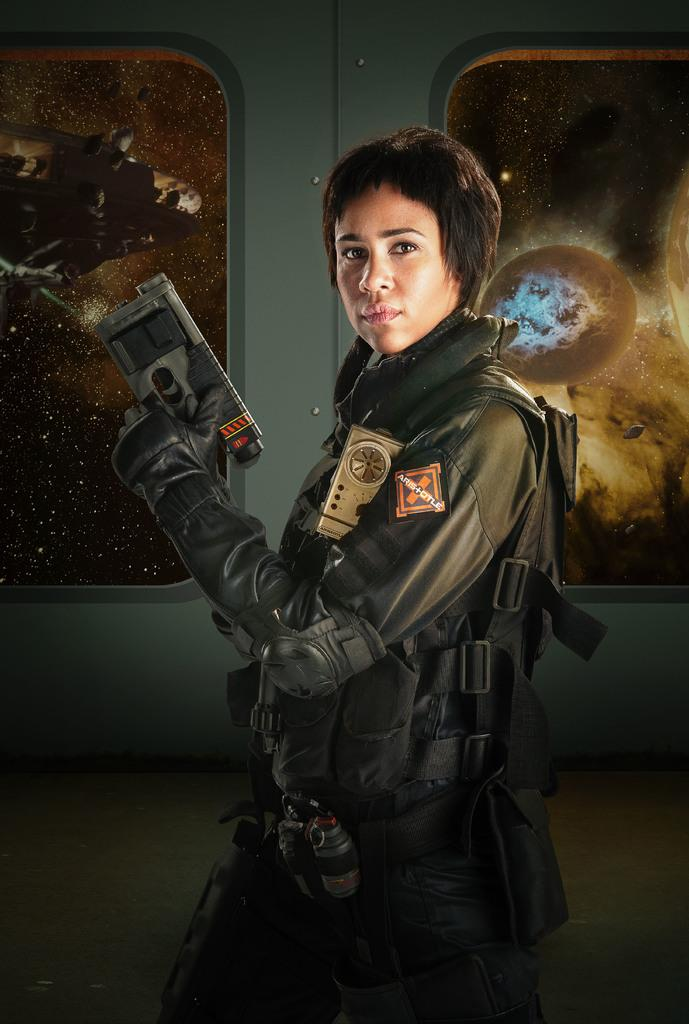Who is present in the image? There is a lady in the image. What is the lady holding in the image? The lady is holding a gun. What type of clothing is the lady wearing? The lady is wearing a jacket. What can be seen in the background of the image? There is a wall in the background of the image, and there are images on the wall. How much money is the lady holding in the image? The lady is not holding any money in the image; she is holding a gun. What time of day is depicted in the image? The time of day is not mentioned in the image, so it cannot be determined. 